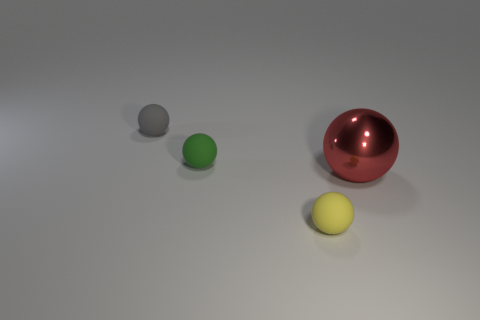Subtract all big red shiny balls. How many balls are left? 3 Add 4 gray rubber things. How many objects exist? 8 Subtract all yellow balls. How many balls are left? 3 Add 1 gray shiny cubes. How many gray shiny cubes exist? 1 Subtract 0 blue cylinders. How many objects are left? 4 Subtract all gray balls. Subtract all red cylinders. How many balls are left? 3 Subtract all yellow metallic cubes. Subtract all green rubber things. How many objects are left? 3 Add 1 large objects. How many large objects are left? 2 